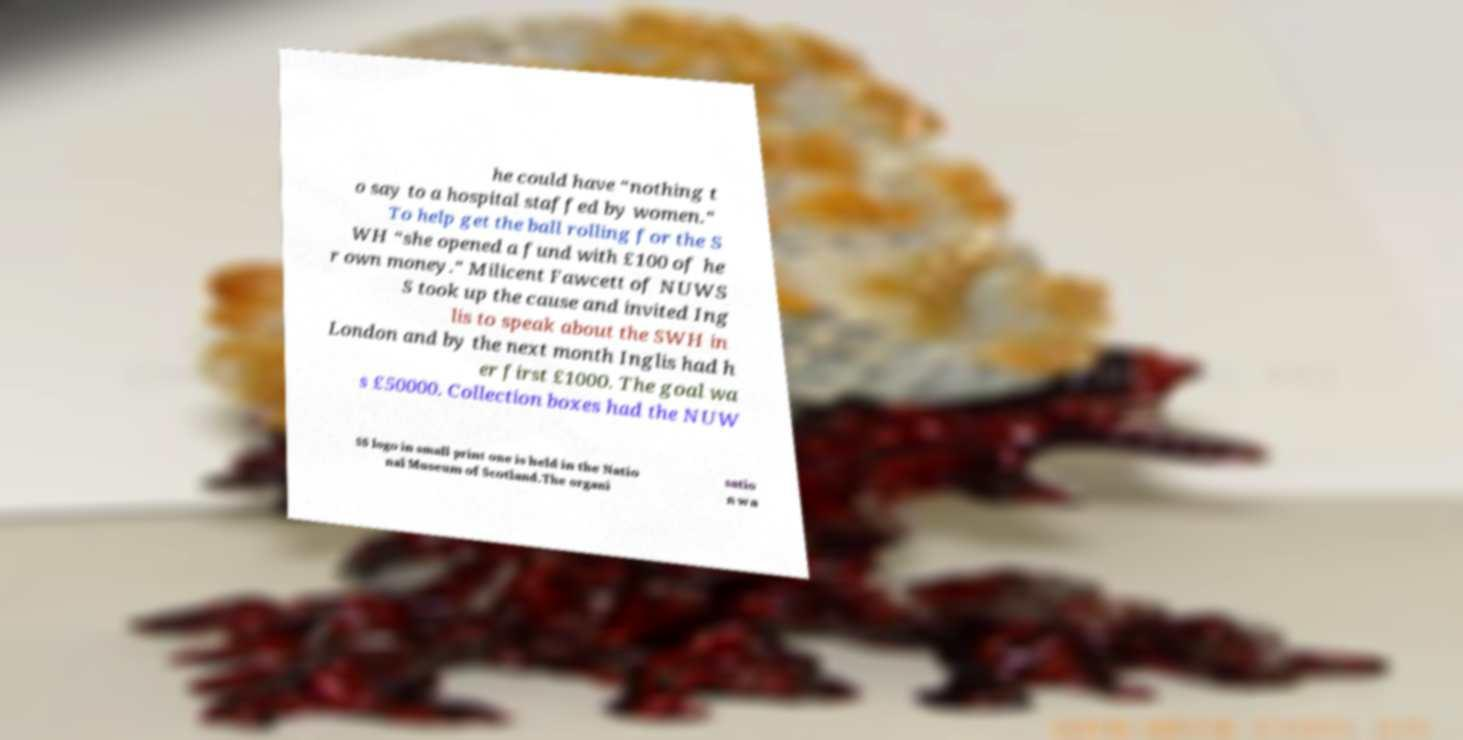Please identify and transcribe the text found in this image. he could have “nothing t o say to a hospital staffed by women.” To help get the ball rolling for the S WH “she opened a fund with £100 of he r own money.” Milicent Fawcett of NUWS S took up the cause and invited Ing lis to speak about the SWH in London and by the next month Inglis had h er first £1000. The goal wa s £50000. Collection boxes had the NUW SS logo in small print one is held in the Natio nal Museum of Scotland.The organi satio n wa 